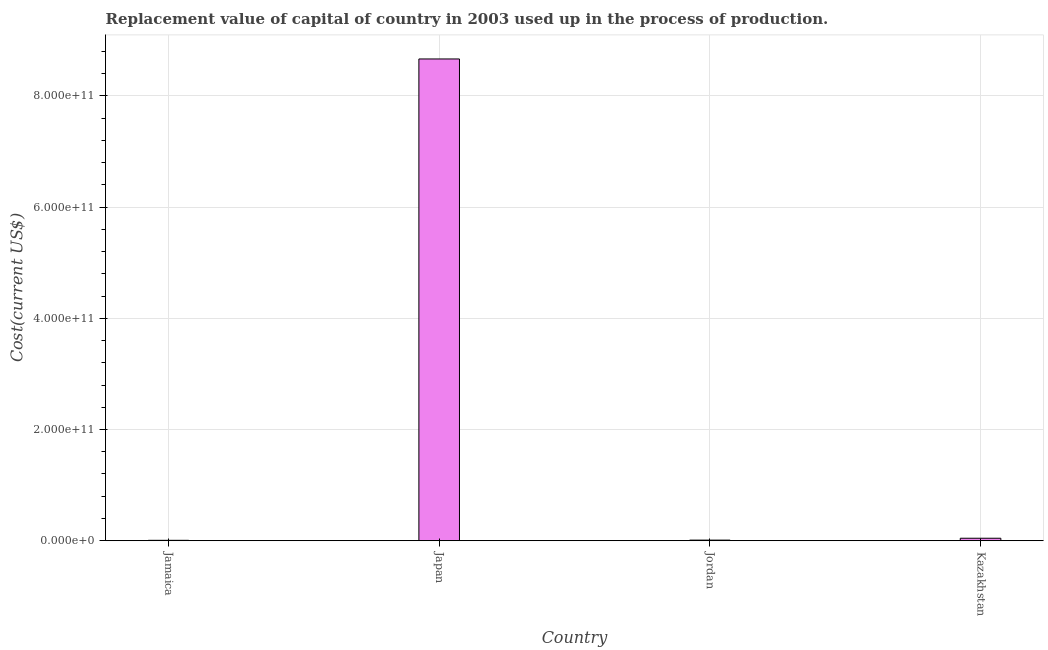Does the graph contain any zero values?
Offer a terse response. No. What is the title of the graph?
Give a very brief answer. Replacement value of capital of country in 2003 used up in the process of production. What is the label or title of the Y-axis?
Provide a succinct answer. Cost(current US$). What is the consumption of fixed capital in Jamaica?
Your response must be concise. 7.20e+08. Across all countries, what is the maximum consumption of fixed capital?
Offer a terse response. 8.66e+11. Across all countries, what is the minimum consumption of fixed capital?
Offer a terse response. 7.20e+08. In which country was the consumption of fixed capital minimum?
Give a very brief answer. Jamaica. What is the sum of the consumption of fixed capital?
Keep it short and to the point. 8.73e+11. What is the difference between the consumption of fixed capital in Jamaica and Kazakhstan?
Give a very brief answer. -3.73e+09. What is the average consumption of fixed capital per country?
Ensure brevity in your answer.  2.18e+11. What is the median consumption of fixed capital?
Your answer should be compact. 2.77e+09. In how many countries, is the consumption of fixed capital greater than 600000000000 US$?
Make the answer very short. 1. What is the ratio of the consumption of fixed capital in Jamaica to that in Jordan?
Provide a short and direct response. 0.67. Is the consumption of fixed capital in Jordan less than that in Kazakhstan?
Offer a very short reply. Yes. What is the difference between the highest and the second highest consumption of fixed capital?
Your answer should be very brief. 8.62e+11. What is the difference between the highest and the lowest consumption of fixed capital?
Your answer should be compact. 8.66e+11. In how many countries, is the consumption of fixed capital greater than the average consumption of fixed capital taken over all countries?
Provide a succinct answer. 1. How many bars are there?
Offer a terse response. 4. How many countries are there in the graph?
Your answer should be compact. 4. What is the difference between two consecutive major ticks on the Y-axis?
Provide a succinct answer. 2.00e+11. Are the values on the major ticks of Y-axis written in scientific E-notation?
Make the answer very short. Yes. What is the Cost(current US$) of Jamaica?
Offer a terse response. 7.20e+08. What is the Cost(current US$) of Japan?
Offer a very short reply. 8.66e+11. What is the Cost(current US$) in Jordan?
Ensure brevity in your answer.  1.08e+09. What is the Cost(current US$) in Kazakhstan?
Make the answer very short. 4.45e+09. What is the difference between the Cost(current US$) in Jamaica and Japan?
Make the answer very short. -8.66e+11. What is the difference between the Cost(current US$) in Jamaica and Jordan?
Your answer should be compact. -3.62e+08. What is the difference between the Cost(current US$) in Jamaica and Kazakhstan?
Give a very brief answer. -3.73e+09. What is the difference between the Cost(current US$) in Japan and Jordan?
Your answer should be compact. 8.65e+11. What is the difference between the Cost(current US$) in Japan and Kazakhstan?
Provide a succinct answer. 8.62e+11. What is the difference between the Cost(current US$) in Jordan and Kazakhstan?
Keep it short and to the point. -3.37e+09. What is the ratio of the Cost(current US$) in Jamaica to that in Jordan?
Ensure brevity in your answer.  0.67. What is the ratio of the Cost(current US$) in Jamaica to that in Kazakhstan?
Keep it short and to the point. 0.16. What is the ratio of the Cost(current US$) in Japan to that in Jordan?
Give a very brief answer. 801. What is the ratio of the Cost(current US$) in Japan to that in Kazakhstan?
Ensure brevity in your answer.  194.51. What is the ratio of the Cost(current US$) in Jordan to that in Kazakhstan?
Your answer should be compact. 0.24. 